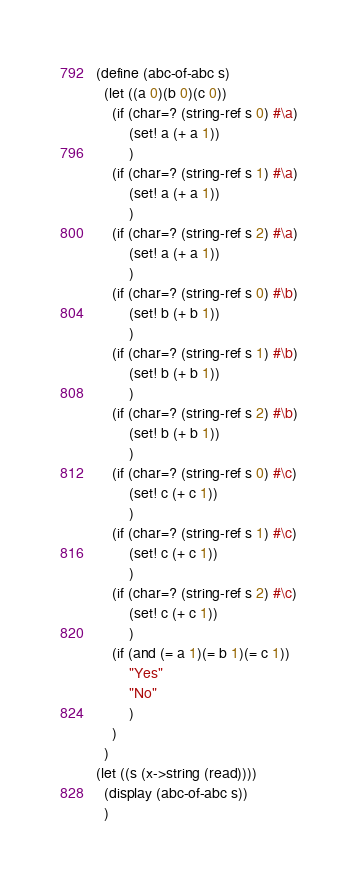Convert code to text. <code><loc_0><loc_0><loc_500><loc_500><_Scheme_>(define (abc-of-abc s)
  (let ((a 0)(b 0)(c 0))
    (if (char=? (string-ref s 0) #\a)
        (set! a (+ a 1))
        )
    (if (char=? (string-ref s 1) #\a)
        (set! a (+ a 1))
        )
    (if (char=? (string-ref s 2) #\a)
        (set! a (+ a 1))
        )
    (if (char=? (string-ref s 0) #\b)
        (set! b (+ b 1))
        )
    (if (char=? (string-ref s 1) #\b)
        (set! b (+ b 1))
        )
    (if (char=? (string-ref s 2) #\b)
        (set! b (+ b 1))
        )
    (if (char=? (string-ref s 0) #\c)
        (set! c (+ c 1))
        )
    (if (char=? (string-ref s 1) #\c)
        (set! c (+ c 1))
        )
    (if (char=? (string-ref s 2) #\c)
        (set! c (+ c 1))
        )
    (if (and (= a 1)(= b 1)(= c 1))
        "Yes"
        "No"
        )
    )
  )
(let ((s (x->string (read))))
  (display (abc-of-abc s))
  )


</code> 